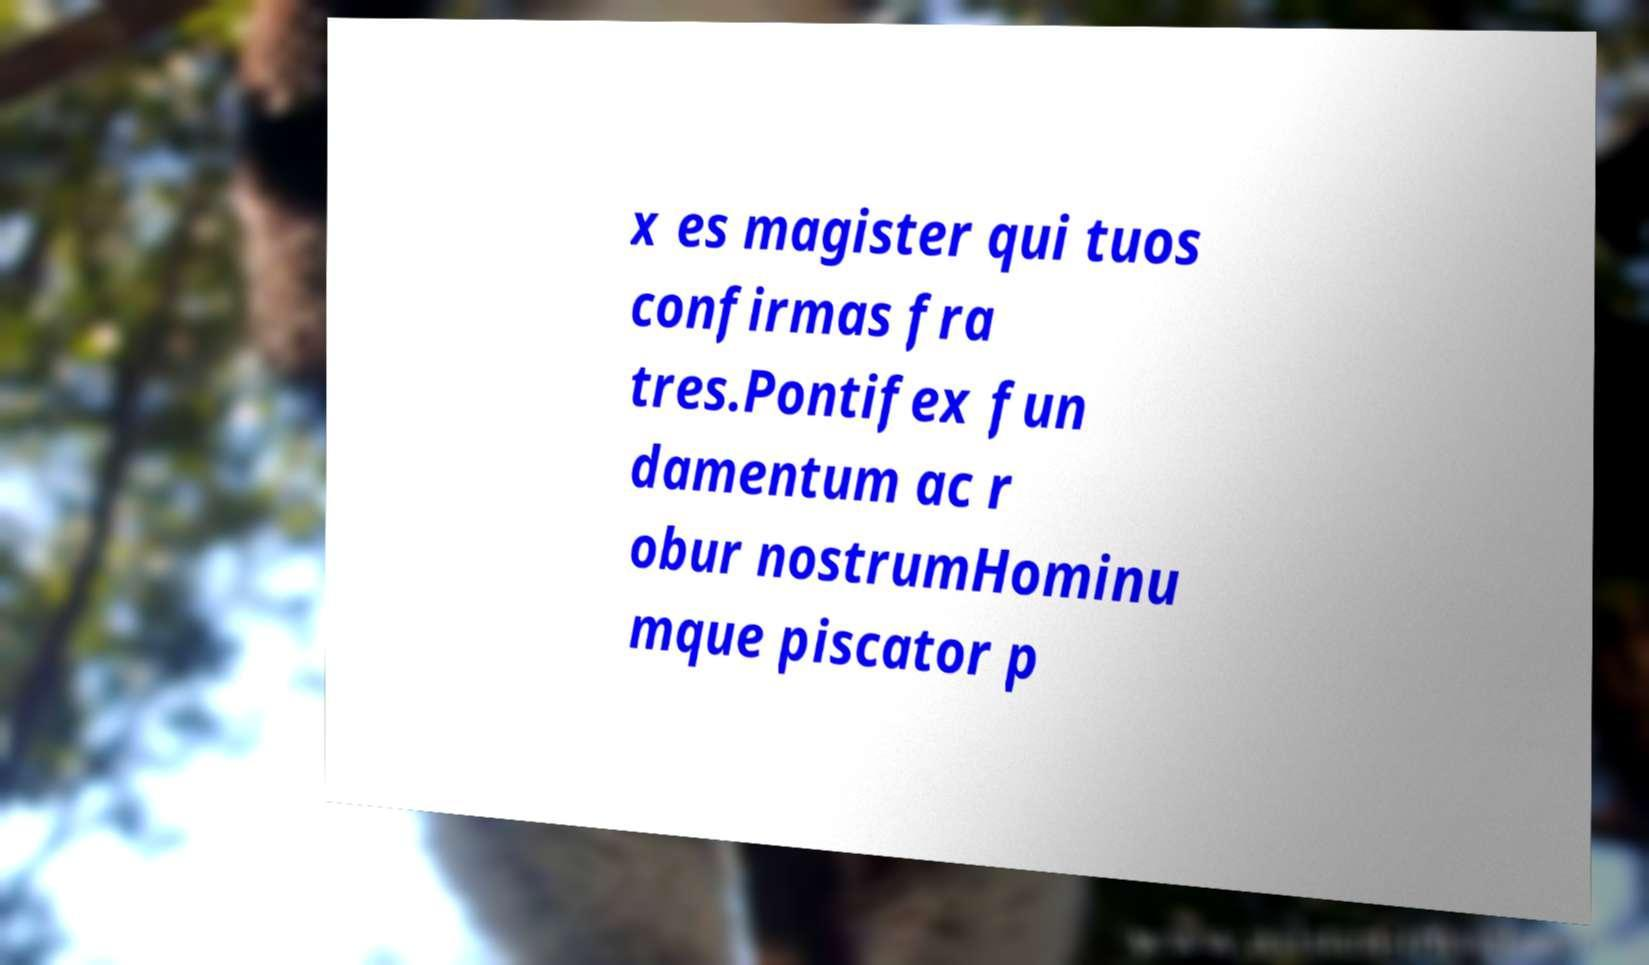What messages or text are displayed in this image? I need them in a readable, typed format. x es magister qui tuos confirmas fra tres.Pontifex fun damentum ac r obur nostrumHominu mque piscator p 